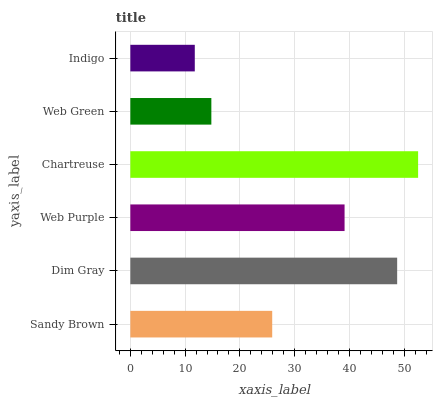Is Indigo the minimum?
Answer yes or no. Yes. Is Chartreuse the maximum?
Answer yes or no. Yes. Is Dim Gray the minimum?
Answer yes or no. No. Is Dim Gray the maximum?
Answer yes or no. No. Is Dim Gray greater than Sandy Brown?
Answer yes or no. Yes. Is Sandy Brown less than Dim Gray?
Answer yes or no. Yes. Is Sandy Brown greater than Dim Gray?
Answer yes or no. No. Is Dim Gray less than Sandy Brown?
Answer yes or no. No. Is Web Purple the high median?
Answer yes or no. Yes. Is Sandy Brown the low median?
Answer yes or no. Yes. Is Dim Gray the high median?
Answer yes or no. No. Is Indigo the low median?
Answer yes or no. No. 